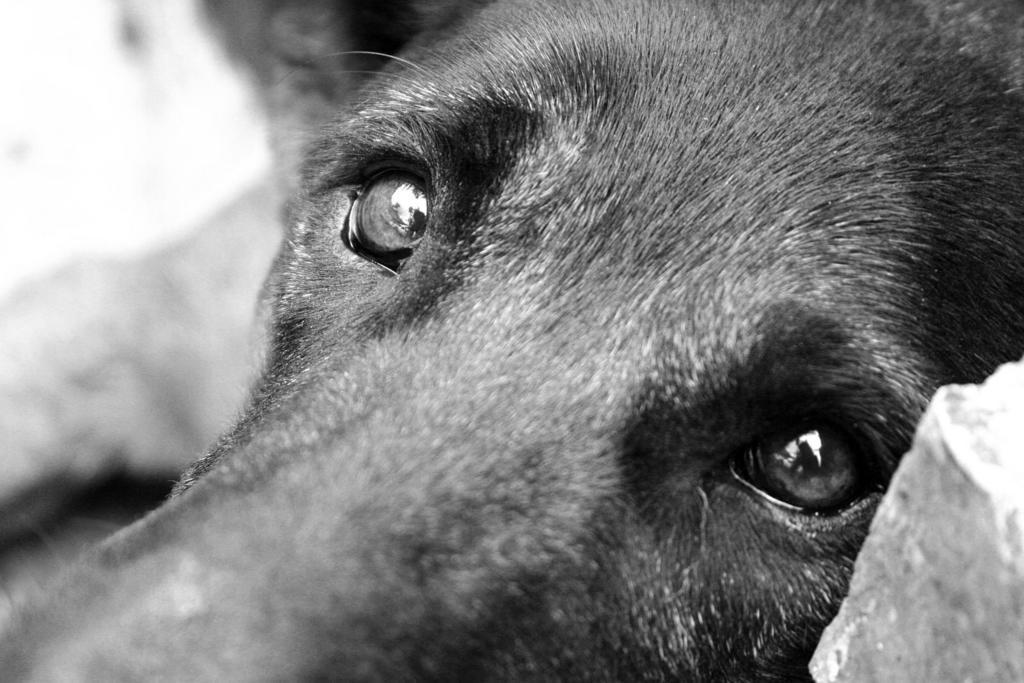How would you summarize this image in a sentence or two? This is a zoomed in picture. In the foreground we can see the head and the eyes of an animal seems to be a dog. The background of the image is blurry. 